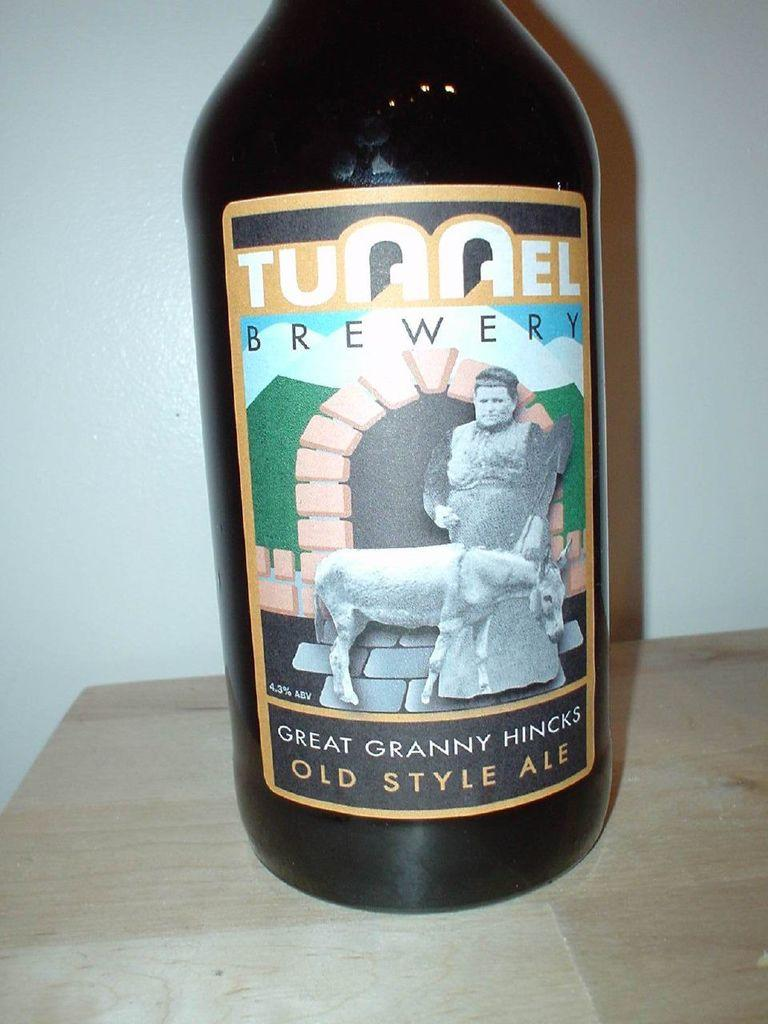Provide a one-sentence caption for the provided image. The bottle contains old style ale from Tunnel Brewery. 